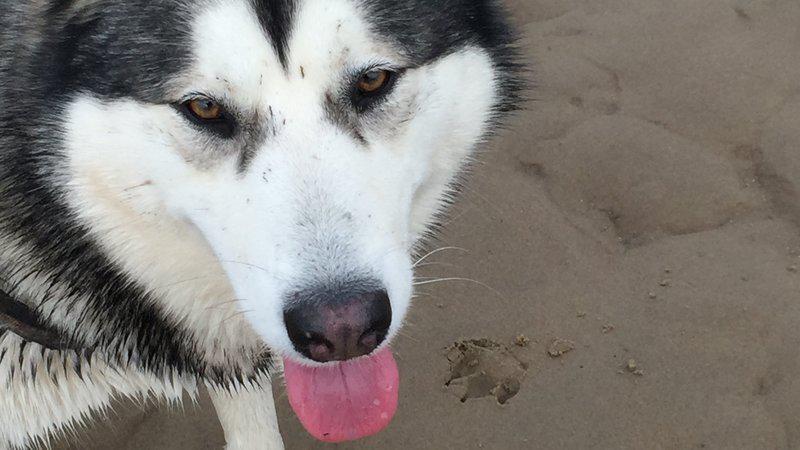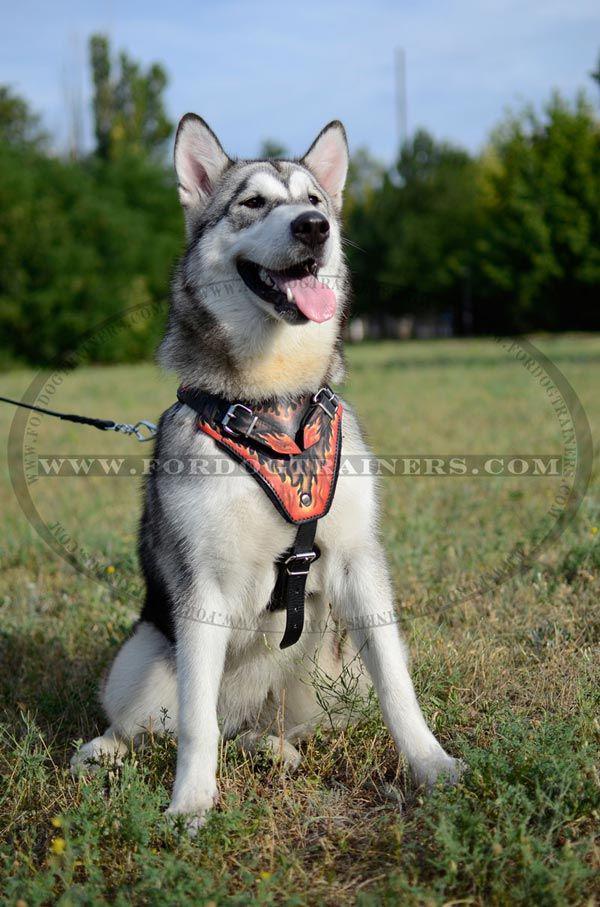The first image is the image on the left, the second image is the image on the right. For the images shown, is this caption "The dog in the image on the left has its tail up and curled over its back." true? Answer yes or no. No. The first image is the image on the left, the second image is the image on the right. Analyze the images presented: Is the assertion "Both dogs have their tongues out." valid? Answer yes or no. Yes. 